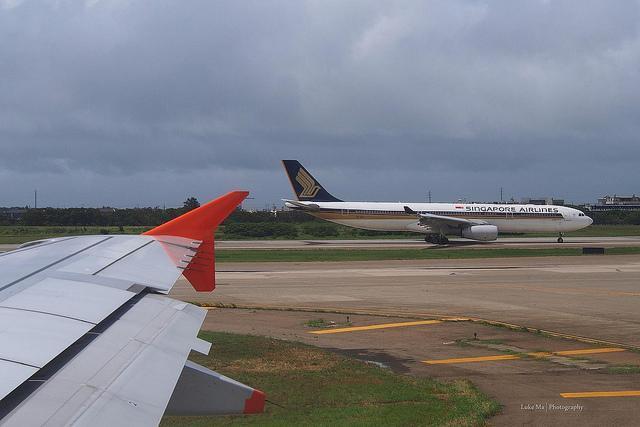How many planes are on the ground?
Give a very brief answer. 2. How many airplanes are in the photo?
Give a very brief answer. 2. 